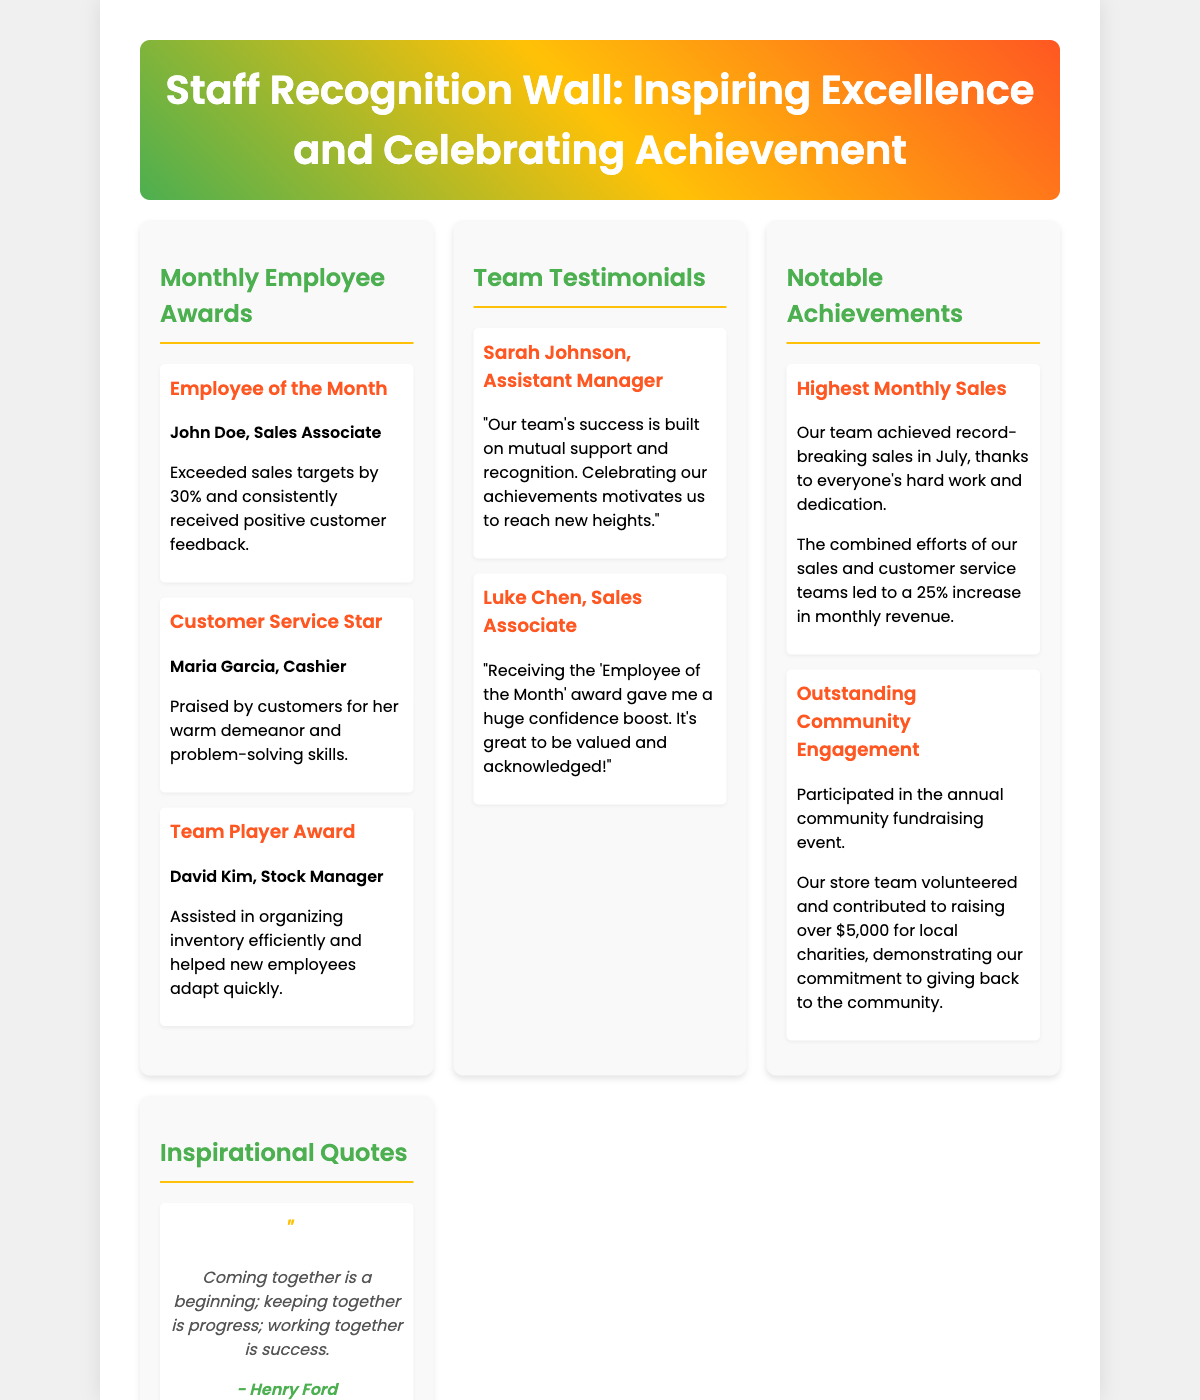what is the main title of the poster? The main title is displayed prominently at the top of the poster.
Answer: Staff Recognition Wall: Inspiring Excellence and Celebrating Achievement who received the Employee of the Month award? The Employee of the Month award highlights a specific individual recognized for their achievements.
Answer: John Doe how many testimonials are included in the document? The document lists a specific number of testimonials provided by team members.
Answer: 2 what percentage did the team exceed monthly revenue by? This percentage is mentioned in the section about notable achievements.
Answer: 25% which award did Maria Garcia receive? This award is specifically listed under the Monthly Employee Awards section.
Answer: Customer Service Star what is the primary color theme used in the header? The color theme of the header gives a vibrant and motivational feel to the poster.
Answer: Gradient of green, yellow, and orange how much money was raised for local charities during the community event? This fundraising detail is included in the notable achievements section.
Answer: $5,000 who is quoted saying "Coming together is a beginning; keeping together is progress; working together is success."? The author of the quote is credited beneath the quote in the Inspirational Quotes section.
Answer: Henry Ford what is featured in the images at the bottom of the poster? The images depict specific team achievements and recognition events.
Answer: Team photo with awards and Employee of the Month 